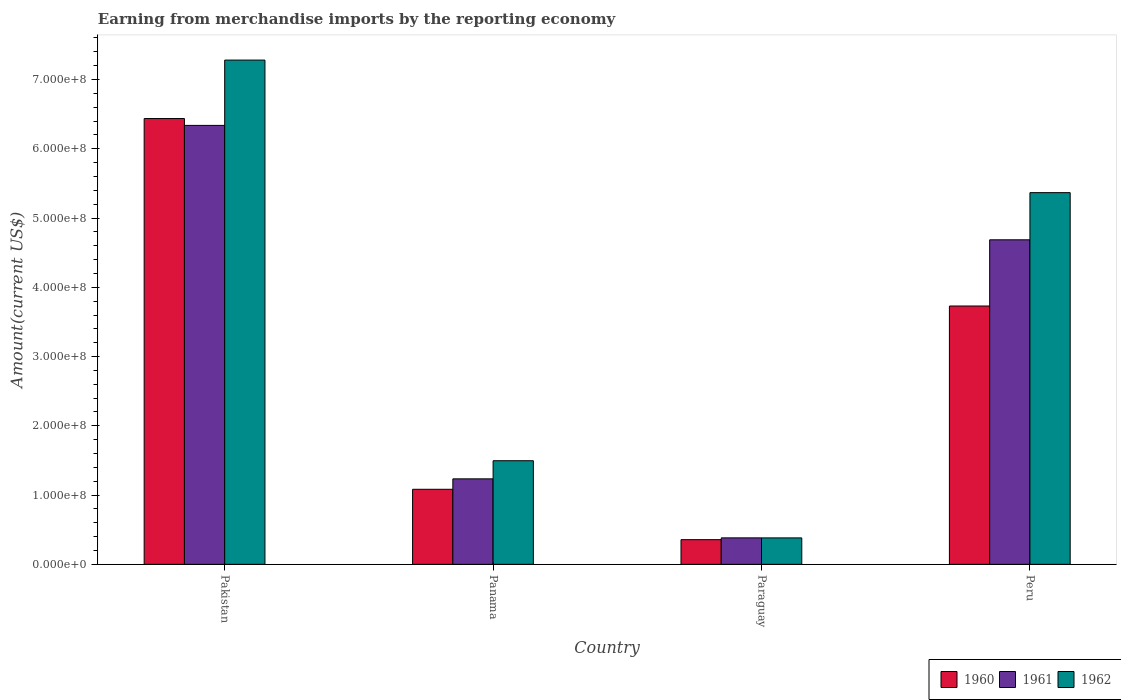How many groups of bars are there?
Provide a succinct answer. 4. Are the number of bars on each tick of the X-axis equal?
Your answer should be very brief. Yes. How many bars are there on the 2nd tick from the left?
Your answer should be very brief. 3. How many bars are there on the 2nd tick from the right?
Ensure brevity in your answer.  3. What is the label of the 3rd group of bars from the left?
Make the answer very short. Paraguay. In how many cases, is the number of bars for a given country not equal to the number of legend labels?
Give a very brief answer. 0. What is the amount earned from merchandise imports in 1960 in Peru?
Make the answer very short. 3.73e+08. Across all countries, what is the maximum amount earned from merchandise imports in 1961?
Keep it short and to the point. 6.34e+08. Across all countries, what is the minimum amount earned from merchandise imports in 1961?
Offer a very short reply. 3.82e+07. In which country was the amount earned from merchandise imports in 1960 maximum?
Give a very brief answer. Pakistan. In which country was the amount earned from merchandise imports in 1960 minimum?
Make the answer very short. Paraguay. What is the total amount earned from merchandise imports in 1962 in the graph?
Your answer should be very brief. 1.45e+09. What is the difference between the amount earned from merchandise imports in 1962 in Paraguay and that in Peru?
Provide a short and direct response. -4.99e+08. What is the difference between the amount earned from merchandise imports in 1962 in Peru and the amount earned from merchandise imports in 1960 in Paraguay?
Provide a succinct answer. 5.01e+08. What is the average amount earned from merchandise imports in 1960 per country?
Your answer should be compact. 2.90e+08. What is the difference between the amount earned from merchandise imports of/in 1962 and amount earned from merchandise imports of/in 1960 in Paraguay?
Your answer should be compact. 2.55e+06. What is the ratio of the amount earned from merchandise imports in 1961 in Panama to that in Paraguay?
Your response must be concise. 3.23. Is the difference between the amount earned from merchandise imports in 1962 in Panama and Peru greater than the difference between the amount earned from merchandise imports in 1960 in Panama and Peru?
Your answer should be compact. No. What is the difference between the highest and the second highest amount earned from merchandise imports in 1960?
Keep it short and to the point. 5.35e+08. What is the difference between the highest and the lowest amount earned from merchandise imports in 1961?
Your answer should be compact. 5.96e+08. Is the sum of the amount earned from merchandise imports in 1961 in Panama and Paraguay greater than the maximum amount earned from merchandise imports in 1962 across all countries?
Offer a terse response. No. Is it the case that in every country, the sum of the amount earned from merchandise imports in 1962 and amount earned from merchandise imports in 1960 is greater than the amount earned from merchandise imports in 1961?
Provide a short and direct response. Yes. How many bars are there?
Make the answer very short. 12. Are all the bars in the graph horizontal?
Provide a succinct answer. No. How many countries are there in the graph?
Offer a very short reply. 4. What is the difference between two consecutive major ticks on the Y-axis?
Offer a terse response. 1.00e+08. Where does the legend appear in the graph?
Offer a terse response. Bottom right. What is the title of the graph?
Keep it short and to the point. Earning from merchandise imports by the reporting economy. Does "1999" appear as one of the legend labels in the graph?
Your answer should be compact. No. What is the label or title of the X-axis?
Your answer should be very brief. Country. What is the label or title of the Y-axis?
Your response must be concise. Amount(current US$). What is the Amount(current US$) of 1960 in Pakistan?
Ensure brevity in your answer.  6.44e+08. What is the Amount(current US$) in 1961 in Pakistan?
Your answer should be compact. 6.34e+08. What is the Amount(current US$) in 1962 in Pakistan?
Provide a succinct answer. 7.28e+08. What is the Amount(current US$) of 1960 in Panama?
Provide a short and direct response. 1.08e+08. What is the Amount(current US$) of 1961 in Panama?
Give a very brief answer. 1.23e+08. What is the Amount(current US$) of 1962 in Panama?
Keep it short and to the point. 1.50e+08. What is the Amount(current US$) of 1960 in Paraguay?
Your answer should be compact. 3.56e+07. What is the Amount(current US$) in 1961 in Paraguay?
Offer a terse response. 3.82e+07. What is the Amount(current US$) of 1962 in Paraguay?
Your response must be concise. 3.82e+07. What is the Amount(current US$) in 1960 in Peru?
Offer a terse response. 3.73e+08. What is the Amount(current US$) of 1961 in Peru?
Your response must be concise. 4.69e+08. What is the Amount(current US$) of 1962 in Peru?
Your answer should be very brief. 5.37e+08. Across all countries, what is the maximum Amount(current US$) of 1960?
Ensure brevity in your answer.  6.44e+08. Across all countries, what is the maximum Amount(current US$) of 1961?
Your answer should be compact. 6.34e+08. Across all countries, what is the maximum Amount(current US$) in 1962?
Make the answer very short. 7.28e+08. Across all countries, what is the minimum Amount(current US$) of 1960?
Your response must be concise. 3.56e+07. Across all countries, what is the minimum Amount(current US$) in 1961?
Provide a succinct answer. 3.82e+07. Across all countries, what is the minimum Amount(current US$) of 1962?
Your answer should be compact. 3.82e+07. What is the total Amount(current US$) in 1960 in the graph?
Provide a short and direct response. 1.16e+09. What is the total Amount(current US$) in 1961 in the graph?
Ensure brevity in your answer.  1.26e+09. What is the total Amount(current US$) of 1962 in the graph?
Offer a terse response. 1.45e+09. What is the difference between the Amount(current US$) in 1960 in Pakistan and that in Panama?
Provide a succinct answer. 5.35e+08. What is the difference between the Amount(current US$) of 1961 in Pakistan and that in Panama?
Give a very brief answer. 5.10e+08. What is the difference between the Amount(current US$) of 1962 in Pakistan and that in Panama?
Your answer should be compact. 5.78e+08. What is the difference between the Amount(current US$) in 1960 in Pakistan and that in Paraguay?
Your answer should be very brief. 6.08e+08. What is the difference between the Amount(current US$) of 1961 in Pakistan and that in Paraguay?
Provide a succinct answer. 5.96e+08. What is the difference between the Amount(current US$) in 1962 in Pakistan and that in Paraguay?
Ensure brevity in your answer.  6.90e+08. What is the difference between the Amount(current US$) in 1960 in Pakistan and that in Peru?
Keep it short and to the point. 2.71e+08. What is the difference between the Amount(current US$) in 1961 in Pakistan and that in Peru?
Offer a very short reply. 1.65e+08. What is the difference between the Amount(current US$) in 1962 in Pakistan and that in Peru?
Your answer should be very brief. 1.91e+08. What is the difference between the Amount(current US$) in 1960 in Panama and that in Paraguay?
Offer a terse response. 7.27e+07. What is the difference between the Amount(current US$) of 1961 in Panama and that in Paraguay?
Keep it short and to the point. 8.52e+07. What is the difference between the Amount(current US$) in 1962 in Panama and that in Paraguay?
Provide a succinct answer. 1.11e+08. What is the difference between the Amount(current US$) of 1960 in Panama and that in Peru?
Keep it short and to the point. -2.65e+08. What is the difference between the Amount(current US$) of 1961 in Panama and that in Peru?
Ensure brevity in your answer.  -3.45e+08. What is the difference between the Amount(current US$) of 1962 in Panama and that in Peru?
Give a very brief answer. -3.87e+08. What is the difference between the Amount(current US$) of 1960 in Paraguay and that in Peru?
Ensure brevity in your answer.  -3.37e+08. What is the difference between the Amount(current US$) of 1961 in Paraguay and that in Peru?
Keep it short and to the point. -4.30e+08. What is the difference between the Amount(current US$) in 1962 in Paraguay and that in Peru?
Offer a terse response. -4.99e+08. What is the difference between the Amount(current US$) in 1960 in Pakistan and the Amount(current US$) in 1961 in Panama?
Provide a short and direct response. 5.20e+08. What is the difference between the Amount(current US$) in 1960 in Pakistan and the Amount(current US$) in 1962 in Panama?
Make the answer very short. 4.94e+08. What is the difference between the Amount(current US$) in 1961 in Pakistan and the Amount(current US$) in 1962 in Panama?
Your answer should be very brief. 4.84e+08. What is the difference between the Amount(current US$) in 1960 in Pakistan and the Amount(current US$) in 1961 in Paraguay?
Your response must be concise. 6.05e+08. What is the difference between the Amount(current US$) in 1960 in Pakistan and the Amount(current US$) in 1962 in Paraguay?
Your answer should be compact. 6.06e+08. What is the difference between the Amount(current US$) of 1961 in Pakistan and the Amount(current US$) of 1962 in Paraguay?
Your answer should be compact. 5.96e+08. What is the difference between the Amount(current US$) of 1960 in Pakistan and the Amount(current US$) of 1961 in Peru?
Keep it short and to the point. 1.75e+08. What is the difference between the Amount(current US$) of 1960 in Pakistan and the Amount(current US$) of 1962 in Peru?
Make the answer very short. 1.07e+08. What is the difference between the Amount(current US$) of 1961 in Pakistan and the Amount(current US$) of 1962 in Peru?
Ensure brevity in your answer.  9.71e+07. What is the difference between the Amount(current US$) of 1960 in Panama and the Amount(current US$) of 1961 in Paraguay?
Keep it short and to the point. 7.01e+07. What is the difference between the Amount(current US$) in 1960 in Panama and the Amount(current US$) in 1962 in Paraguay?
Offer a very short reply. 7.02e+07. What is the difference between the Amount(current US$) in 1961 in Panama and the Amount(current US$) in 1962 in Paraguay?
Ensure brevity in your answer.  8.52e+07. What is the difference between the Amount(current US$) in 1960 in Panama and the Amount(current US$) in 1961 in Peru?
Ensure brevity in your answer.  -3.60e+08. What is the difference between the Amount(current US$) of 1960 in Panama and the Amount(current US$) of 1962 in Peru?
Make the answer very short. -4.28e+08. What is the difference between the Amount(current US$) of 1961 in Panama and the Amount(current US$) of 1962 in Peru?
Provide a succinct answer. -4.13e+08. What is the difference between the Amount(current US$) in 1960 in Paraguay and the Amount(current US$) in 1961 in Peru?
Ensure brevity in your answer.  -4.33e+08. What is the difference between the Amount(current US$) in 1960 in Paraguay and the Amount(current US$) in 1962 in Peru?
Provide a succinct answer. -5.01e+08. What is the difference between the Amount(current US$) in 1961 in Paraguay and the Amount(current US$) in 1962 in Peru?
Provide a succinct answer. -4.98e+08. What is the average Amount(current US$) in 1960 per country?
Your response must be concise. 2.90e+08. What is the average Amount(current US$) of 1961 per country?
Provide a succinct answer. 3.16e+08. What is the average Amount(current US$) in 1962 per country?
Give a very brief answer. 3.63e+08. What is the difference between the Amount(current US$) in 1960 and Amount(current US$) in 1961 in Pakistan?
Make the answer very short. 9.90e+06. What is the difference between the Amount(current US$) of 1960 and Amount(current US$) of 1962 in Pakistan?
Your answer should be compact. -8.44e+07. What is the difference between the Amount(current US$) in 1961 and Amount(current US$) in 1962 in Pakistan?
Your response must be concise. -9.43e+07. What is the difference between the Amount(current US$) of 1960 and Amount(current US$) of 1961 in Panama?
Your answer should be very brief. -1.51e+07. What is the difference between the Amount(current US$) of 1960 and Amount(current US$) of 1962 in Panama?
Offer a very short reply. -4.12e+07. What is the difference between the Amount(current US$) in 1961 and Amount(current US$) in 1962 in Panama?
Keep it short and to the point. -2.62e+07. What is the difference between the Amount(current US$) in 1960 and Amount(current US$) in 1961 in Paraguay?
Your answer should be compact. -2.59e+06. What is the difference between the Amount(current US$) in 1960 and Amount(current US$) in 1962 in Paraguay?
Offer a very short reply. -2.55e+06. What is the difference between the Amount(current US$) in 1961 and Amount(current US$) in 1962 in Paraguay?
Provide a short and direct response. 3.80e+04. What is the difference between the Amount(current US$) in 1960 and Amount(current US$) in 1961 in Peru?
Your answer should be very brief. -9.56e+07. What is the difference between the Amount(current US$) of 1960 and Amount(current US$) of 1962 in Peru?
Keep it short and to the point. -1.64e+08. What is the difference between the Amount(current US$) in 1961 and Amount(current US$) in 1962 in Peru?
Make the answer very short. -6.81e+07. What is the ratio of the Amount(current US$) in 1960 in Pakistan to that in Panama?
Give a very brief answer. 5.94. What is the ratio of the Amount(current US$) of 1961 in Pakistan to that in Panama?
Provide a short and direct response. 5.14. What is the ratio of the Amount(current US$) of 1962 in Pakistan to that in Panama?
Give a very brief answer. 4.87. What is the ratio of the Amount(current US$) of 1960 in Pakistan to that in Paraguay?
Your response must be concise. 18.07. What is the ratio of the Amount(current US$) of 1961 in Pakistan to that in Paraguay?
Your response must be concise. 16.59. What is the ratio of the Amount(current US$) in 1962 in Pakistan to that in Paraguay?
Offer a terse response. 19.08. What is the ratio of the Amount(current US$) of 1960 in Pakistan to that in Peru?
Provide a short and direct response. 1.73. What is the ratio of the Amount(current US$) of 1961 in Pakistan to that in Peru?
Offer a terse response. 1.35. What is the ratio of the Amount(current US$) of 1962 in Pakistan to that in Peru?
Provide a short and direct response. 1.36. What is the ratio of the Amount(current US$) of 1960 in Panama to that in Paraguay?
Provide a short and direct response. 3.04. What is the ratio of the Amount(current US$) of 1961 in Panama to that in Paraguay?
Keep it short and to the point. 3.23. What is the ratio of the Amount(current US$) in 1962 in Panama to that in Paraguay?
Offer a very short reply. 3.92. What is the ratio of the Amount(current US$) in 1960 in Panama to that in Peru?
Keep it short and to the point. 0.29. What is the ratio of the Amount(current US$) of 1961 in Panama to that in Peru?
Your response must be concise. 0.26. What is the ratio of the Amount(current US$) in 1962 in Panama to that in Peru?
Make the answer very short. 0.28. What is the ratio of the Amount(current US$) of 1960 in Paraguay to that in Peru?
Offer a very short reply. 0.1. What is the ratio of the Amount(current US$) in 1961 in Paraguay to that in Peru?
Ensure brevity in your answer.  0.08. What is the ratio of the Amount(current US$) in 1962 in Paraguay to that in Peru?
Provide a short and direct response. 0.07. What is the difference between the highest and the second highest Amount(current US$) in 1960?
Your answer should be very brief. 2.71e+08. What is the difference between the highest and the second highest Amount(current US$) of 1961?
Ensure brevity in your answer.  1.65e+08. What is the difference between the highest and the second highest Amount(current US$) in 1962?
Ensure brevity in your answer.  1.91e+08. What is the difference between the highest and the lowest Amount(current US$) of 1960?
Ensure brevity in your answer.  6.08e+08. What is the difference between the highest and the lowest Amount(current US$) of 1961?
Make the answer very short. 5.96e+08. What is the difference between the highest and the lowest Amount(current US$) in 1962?
Make the answer very short. 6.90e+08. 